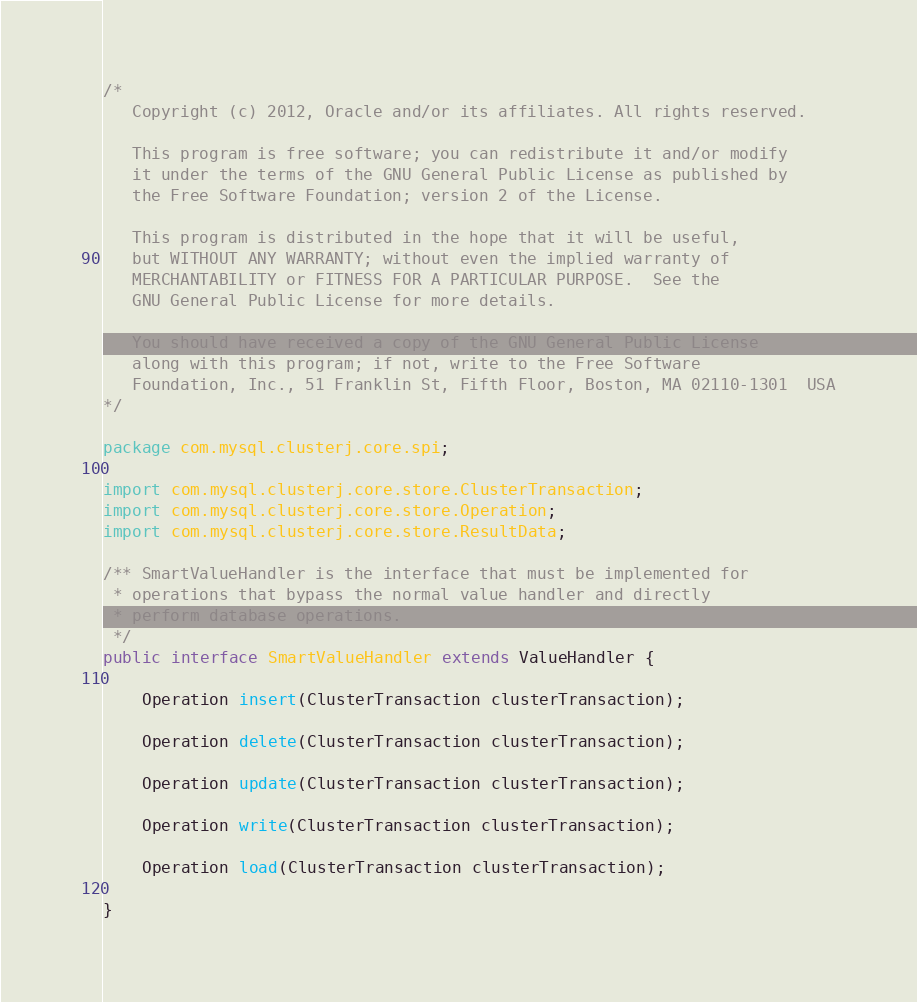<code> <loc_0><loc_0><loc_500><loc_500><_Java_>/*
   Copyright (c) 2012, Oracle and/or its affiliates. All rights reserved.

   This program is free software; you can redistribute it and/or modify
   it under the terms of the GNU General Public License as published by
   the Free Software Foundation; version 2 of the License.

   This program is distributed in the hope that it will be useful,
   but WITHOUT ANY WARRANTY; without even the implied warranty of
   MERCHANTABILITY or FITNESS FOR A PARTICULAR PURPOSE.  See the
   GNU General Public License for more details.

   You should have received a copy of the GNU General Public License
   along with this program; if not, write to the Free Software
   Foundation, Inc., 51 Franklin St, Fifth Floor, Boston, MA 02110-1301  USA
*/

package com.mysql.clusterj.core.spi;

import com.mysql.clusterj.core.store.ClusterTransaction;
import com.mysql.clusterj.core.store.Operation;
import com.mysql.clusterj.core.store.ResultData;

/** SmartValueHandler is the interface that must be implemented for
 * operations that bypass the normal value handler and directly
 * perform database operations.
 */
public interface SmartValueHandler extends ValueHandler {

    Operation insert(ClusterTransaction clusterTransaction);

    Operation delete(ClusterTransaction clusterTransaction);

    Operation update(ClusterTransaction clusterTransaction);

    Operation write(ClusterTransaction clusterTransaction);

    Operation load(ClusterTransaction clusterTransaction);

}
</code> 